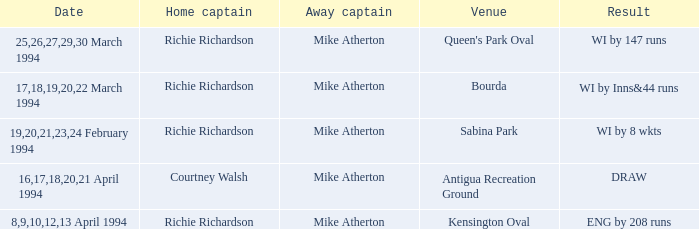What is the result of Courtney Walsh ? DRAW. I'm looking to parse the entire table for insights. Could you assist me with that? {'header': ['Date', 'Home captain', 'Away captain', 'Venue', 'Result'], 'rows': [['25,26,27,29,30 March 1994', 'Richie Richardson', 'Mike Atherton', "Queen's Park Oval", 'WI by 147 runs'], ['17,18,19,20,22 March 1994', 'Richie Richardson', 'Mike Atherton', 'Bourda', 'WI by Inns&44 runs'], ['19,20,21,23,24 February 1994', 'Richie Richardson', 'Mike Atherton', 'Sabina Park', 'WI by 8 wkts'], ['16,17,18,20,21 April 1994', 'Courtney Walsh', 'Mike Atherton', 'Antigua Recreation Ground', 'DRAW'], ['8,9,10,12,13 April 1994', 'Richie Richardson', 'Mike Atherton', 'Kensington Oval', 'ENG by 208 runs']]} 